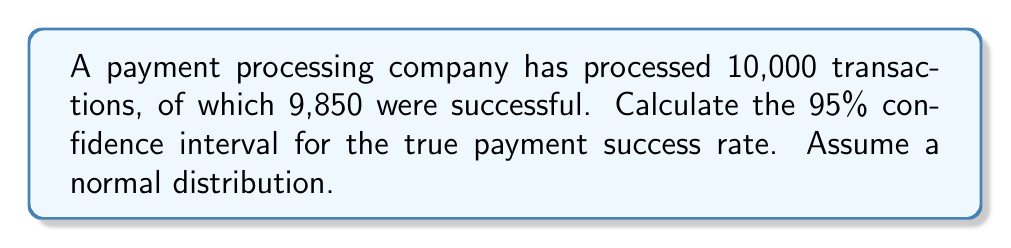Show me your answer to this math problem. To calculate the confidence interval, we'll follow these steps:

1. Calculate the sample proportion (p):
   $$p = \frac{\text{Number of successful transactions}}{\text{Total transactions}} = \frac{9850}{10000} = 0.985$$

2. Calculate the standard error (SE):
   $$SE = \sqrt{\frac{p(1-p)}{n}} = \sqrt{\frac{0.985(1-0.985)}{10000}} = \sqrt{\frac{0.014775}{10000}} = 0.001215$$

3. For a 95% confidence interval, use z = 1.96 (from the standard normal distribution table).

4. Calculate the margin of error (ME):
   $$ME = z \times SE = 1.96 \times 0.001215 = 0.002381$$

5. Calculate the confidence interval:
   Lower bound: $$p - ME = 0.985 - 0.002381 = 0.982619$$
   Upper bound: $$p + ME = 0.985 + 0.002381 = 0.987381$$

Therefore, the 95% confidence interval for the true payment success rate is (0.982619, 0.987381) or (98.26%, 98.74%).
Answer: (0.982619, 0.987381) 